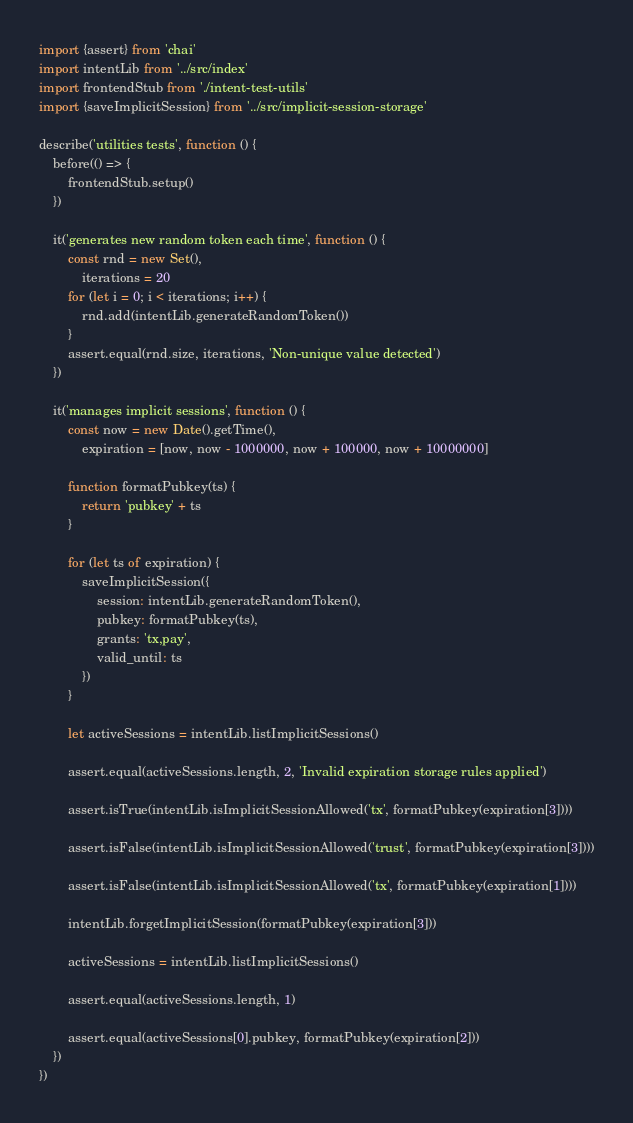Convert code to text. <code><loc_0><loc_0><loc_500><loc_500><_JavaScript_>import {assert} from 'chai'
import intentLib from '../src/index'
import frontendStub from './intent-test-utils'
import {saveImplicitSession} from '../src/implicit-session-storage'

describe('utilities tests', function () {
    before(() => {
        frontendStub.setup()
    })

    it('generates new random token each time', function () {
        const rnd = new Set(),
            iterations = 20
        for (let i = 0; i < iterations; i++) {
            rnd.add(intentLib.generateRandomToken())
        }
        assert.equal(rnd.size, iterations, 'Non-unique value detected')
    })

    it('manages implicit sessions', function () {
        const now = new Date().getTime(),
            expiration = [now, now - 1000000, now + 100000, now + 10000000]

        function formatPubkey(ts) {
            return 'pubkey' + ts
        }

        for (let ts of expiration) {
            saveImplicitSession({
                session: intentLib.generateRandomToken(),
                pubkey: formatPubkey(ts),
                grants: 'tx,pay',
                valid_until: ts
            })
        }

        let activeSessions = intentLib.listImplicitSessions()

        assert.equal(activeSessions.length, 2, 'Invalid expiration storage rules applied')

        assert.isTrue(intentLib.isImplicitSessionAllowed('tx', formatPubkey(expiration[3])))

        assert.isFalse(intentLib.isImplicitSessionAllowed('trust', formatPubkey(expiration[3])))

        assert.isFalse(intentLib.isImplicitSessionAllowed('tx', formatPubkey(expiration[1])))

        intentLib.forgetImplicitSession(formatPubkey(expiration[3]))

        activeSessions = intentLib.listImplicitSessions()

        assert.equal(activeSessions.length, 1)

        assert.equal(activeSessions[0].pubkey, formatPubkey(expiration[2]))
    })
})</code> 